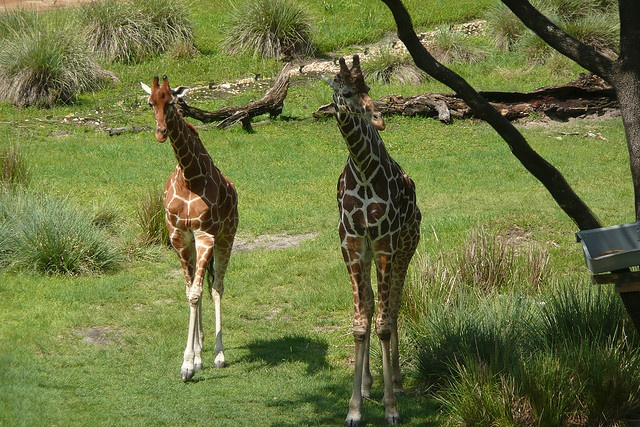Describe the objects in this image and their specific colors. I can see giraffe in tan, black, darkgreen, gray, and olive tones and giraffe in tan, black, olive, maroon, and beige tones in this image. 